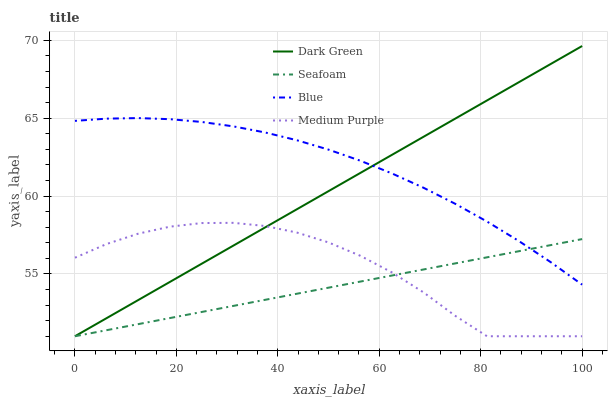Does Seafoam have the minimum area under the curve?
Answer yes or no. Yes. Does Medium Purple have the minimum area under the curve?
Answer yes or no. No. Does Medium Purple have the maximum area under the curve?
Answer yes or no. No. Is Medium Purple the roughest?
Answer yes or no. Yes. Is Medium Purple the smoothest?
Answer yes or no. No. Is Seafoam the roughest?
Answer yes or no. No. Does Medium Purple have the highest value?
Answer yes or no. No. Is Medium Purple less than Blue?
Answer yes or no. Yes. Is Blue greater than Medium Purple?
Answer yes or no. Yes. Does Medium Purple intersect Blue?
Answer yes or no. No. 